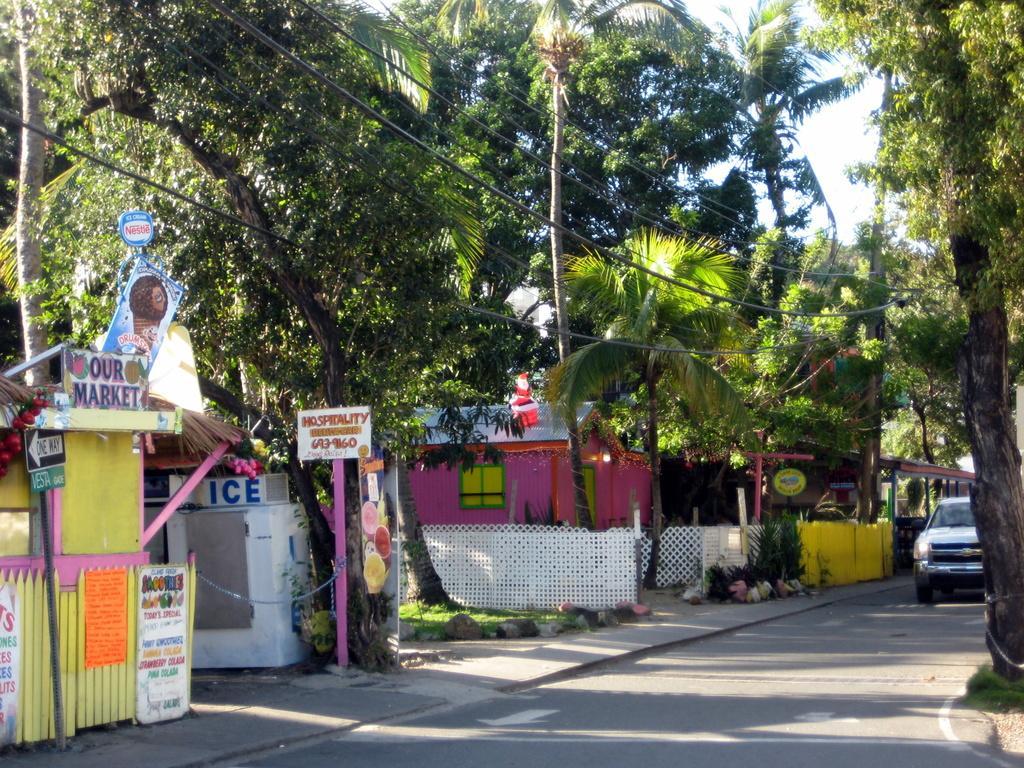How would you summarize this image in a sentence or two? In this picture we can see few sign boards, houses, trees and cables, and also we can find a car on the road. 